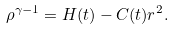Convert formula to latex. <formula><loc_0><loc_0><loc_500><loc_500>\rho ^ { \gamma - 1 } = H ( t ) - C ( t ) r ^ { 2 } .</formula> 